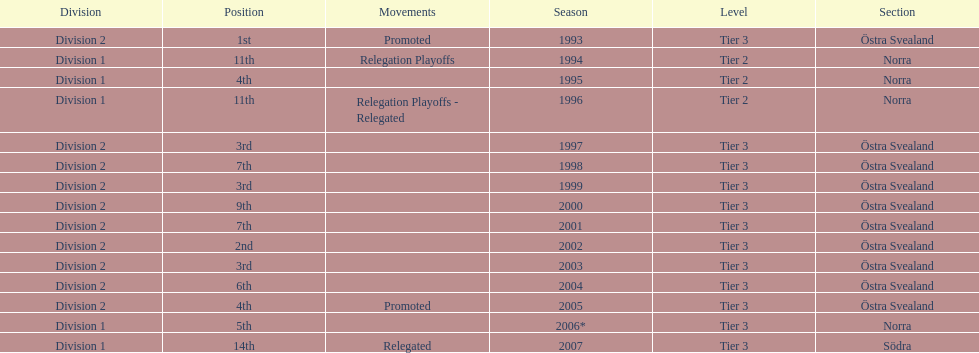How many times is division 2 listed as the division? 10. 